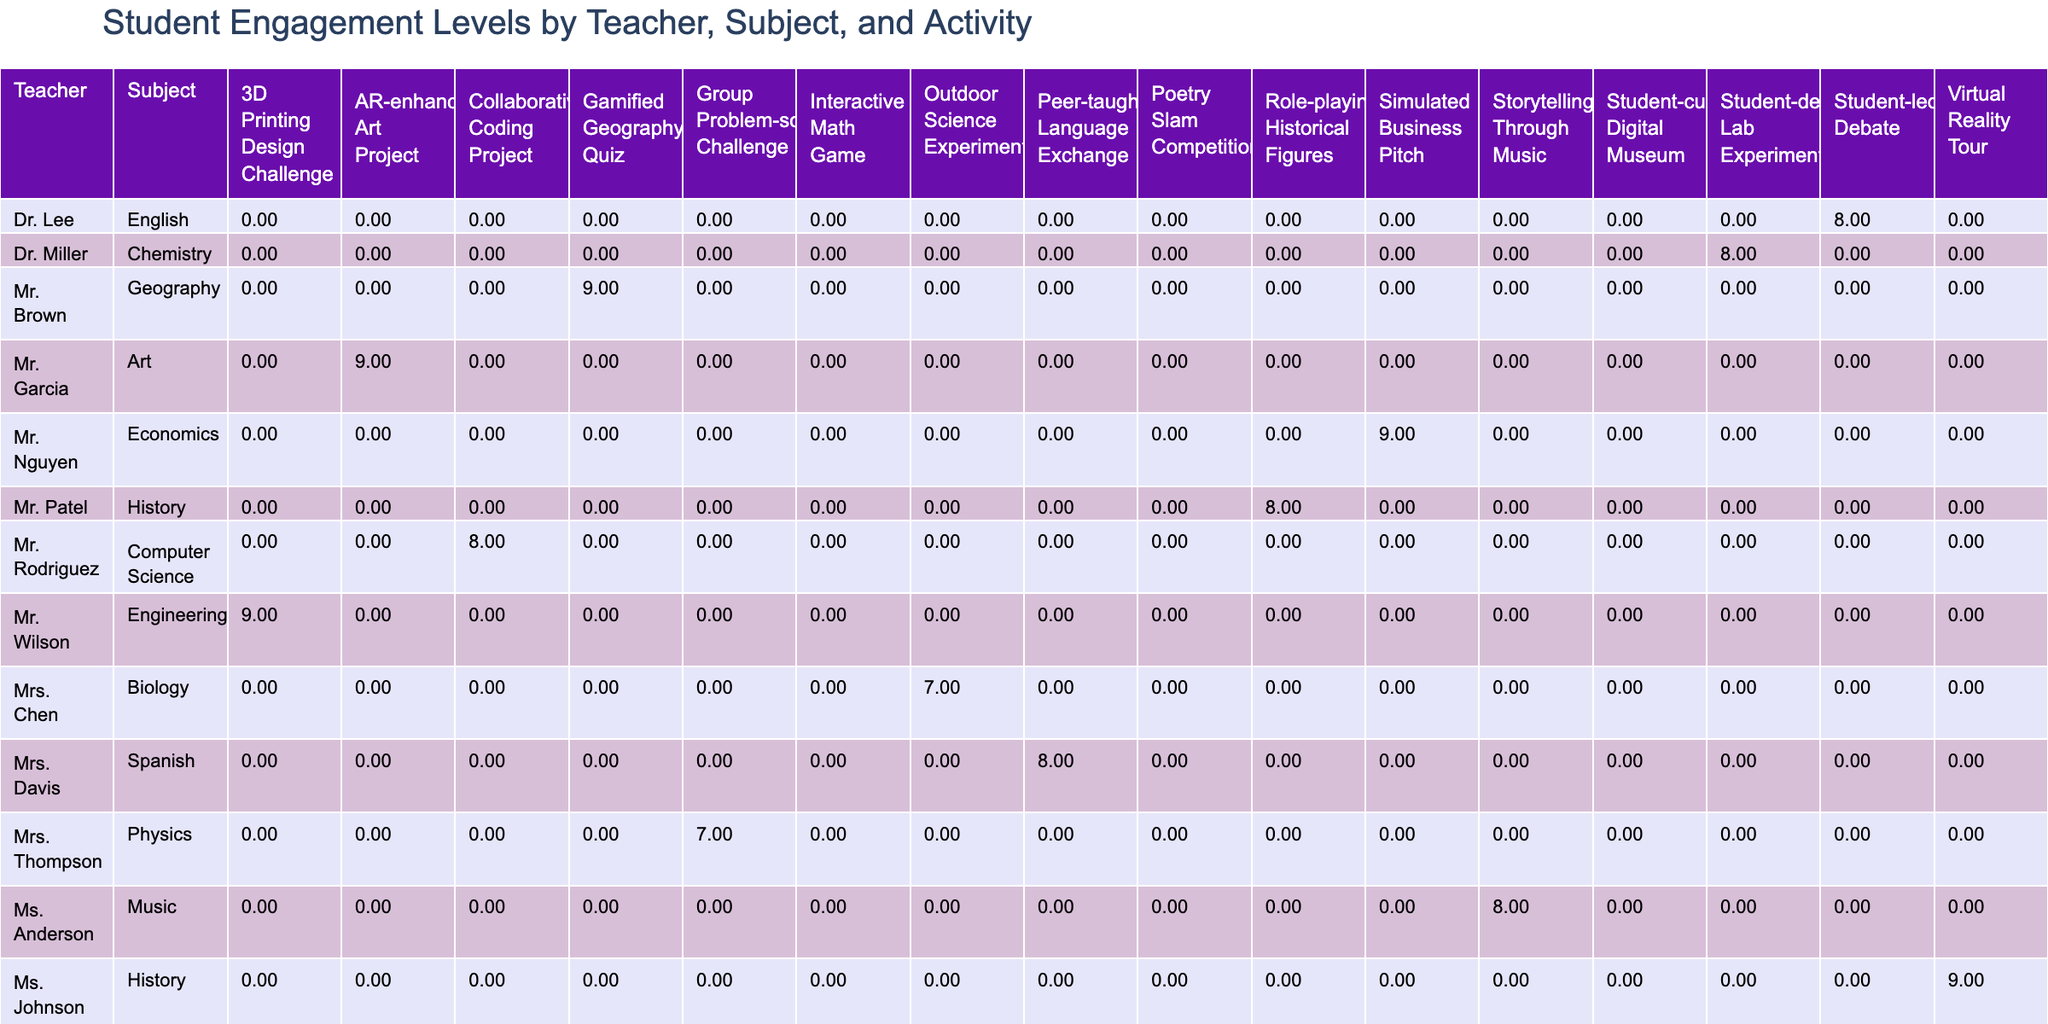What is the highest engagement level achieved and by which activity? The highest engagement level recorded in the table is 9, which is achieved by the activities "Virtual Reality Tour", "Interactive Math Game", "AR-enhanced Art Project", "Simulated Business Pitch", "Gamified Geography Quiz", and "3D Printing Design Challenge".
Answer: 9, several activities How many students participated in the "Outdoor Science Experiment"? The table shows that 25 students participated in the "Outdoor Science Experiment" activity under Mrs. Chen.
Answer: 25 Which subject had the lowest engagement level recorded across all activities? The lowest engagement level recorded in the table is 7, associated with the activities "Outdoor Science Experiment", "Group Problem-solving Challenge", "Poetry Slam Competition", and is linked to the subjects Biology, Physics, and English.
Answer: Biology, Physics, English (7) What is the average engagement level for the activities conducted in English? The engagement levels for English activities are 8 (Student-led Debate) and 7 (Poetry Slam Competition). The average is calculated as (8 + 7) / 2 = 7.5.
Answer: 7.5 Did any teacher conduct more than one activity? If yes, who are they? Yes, Mr. Rodriguez (Computer Science) and Mr. Garcia (Art) each conducted more than one activity.
Answer: Yes, Mr. Rodriguez, Mr. Garcia What is the total engagement level for the activities involving the subject Mathematics? The engagement level for the Mathematics activity "Interactive Math Game" is 9. Therefore, the total engagement level for Mathematics activities is 9.
Answer: 9 Which activity had the least number of students participating and what was the engagement level? The "Group Problem-solving Challenge" had the least number of students participating at 18, with an engagement level of 7.
Answer: Group Problem-solving Challenge, 7 How many different teachers participated in the activities listed and which teacher had the most activities listed? There are 10 different teachers in the list. Mr. Rodriguez and Mr. Garcia had the most activities listed, each conducting one.
Answer: 10 teachers, none had more than 1 activity 